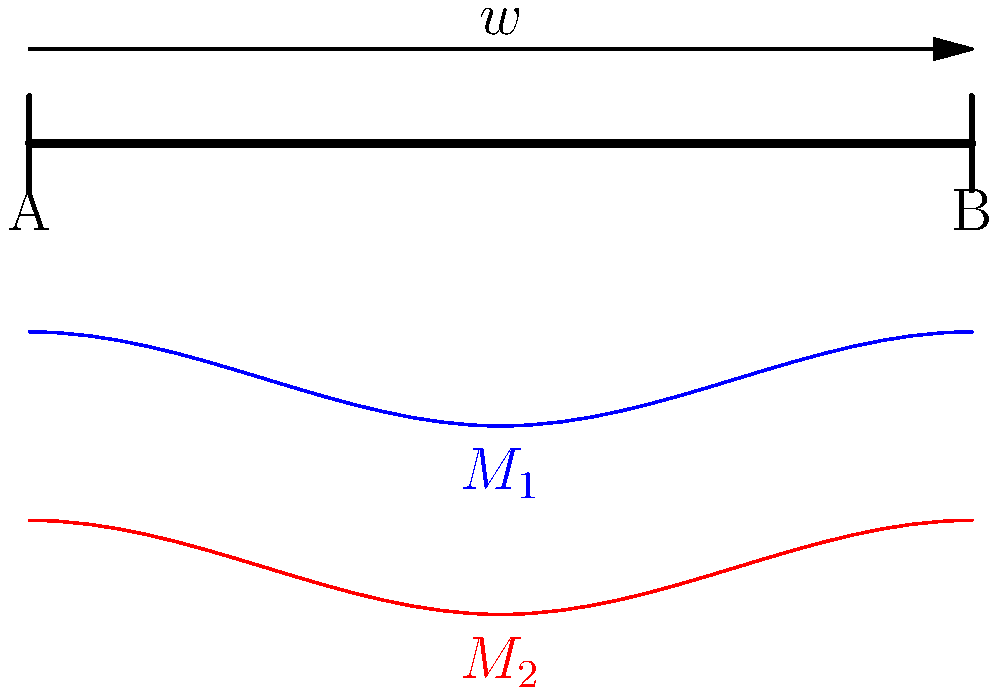As part of a project to improve local infrastructure in Seke, you're analyzing a simply supported beam under a uniformly distributed load. The beam represents a key component in a new bridge design. The image shows two different moment diagrams ($M_1$ and $M_2$) for the same beam. Which moment diagram correctly represents the bending moment distribution for this loading condition, and why? To determine the correct moment diagram, let's analyze the problem step-by-step:

1. The beam is simply supported at both ends (A and B) and subjected to a uniformly distributed load $w$.

2. For a simply supported beam under uniform load, the bending moment distribution follows a parabolic shape.

3. The maximum bending moment occurs at the center of the beam.

4. The bending moment is zero at the supports (ends of the beam).

5. Analyzing the given moment diagrams:
   - $M_1$ (blue) shows a parabolic shape with maximum at the center and zero at the supports.
   - $M_2$ (red) shows an incorrect shape that doesn't match the expected distribution for this loading condition.

6. The correct bending moment equation for a simply supported beam with uniform load $w$ and length $L$ is:

   $$M(x) = \frac{wx}{2}(L-x)$$

   This equation produces a parabolic shape similar to $M_1$.

Therefore, the blue diagram ($M_1$) correctly represents the bending moment distribution for this loading condition.
Answer: $M_1$ (blue diagram) 